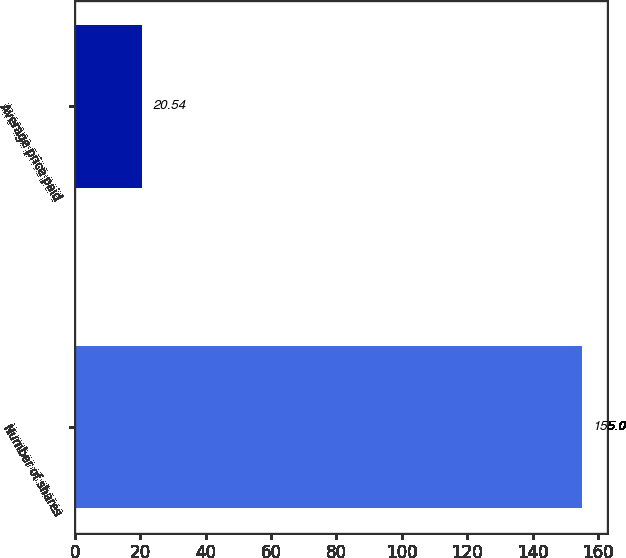Convert chart to OTSL. <chart><loc_0><loc_0><loc_500><loc_500><bar_chart><fcel>Number of shares<fcel>Average price paid<nl><fcel>155<fcel>20.54<nl></chart> 